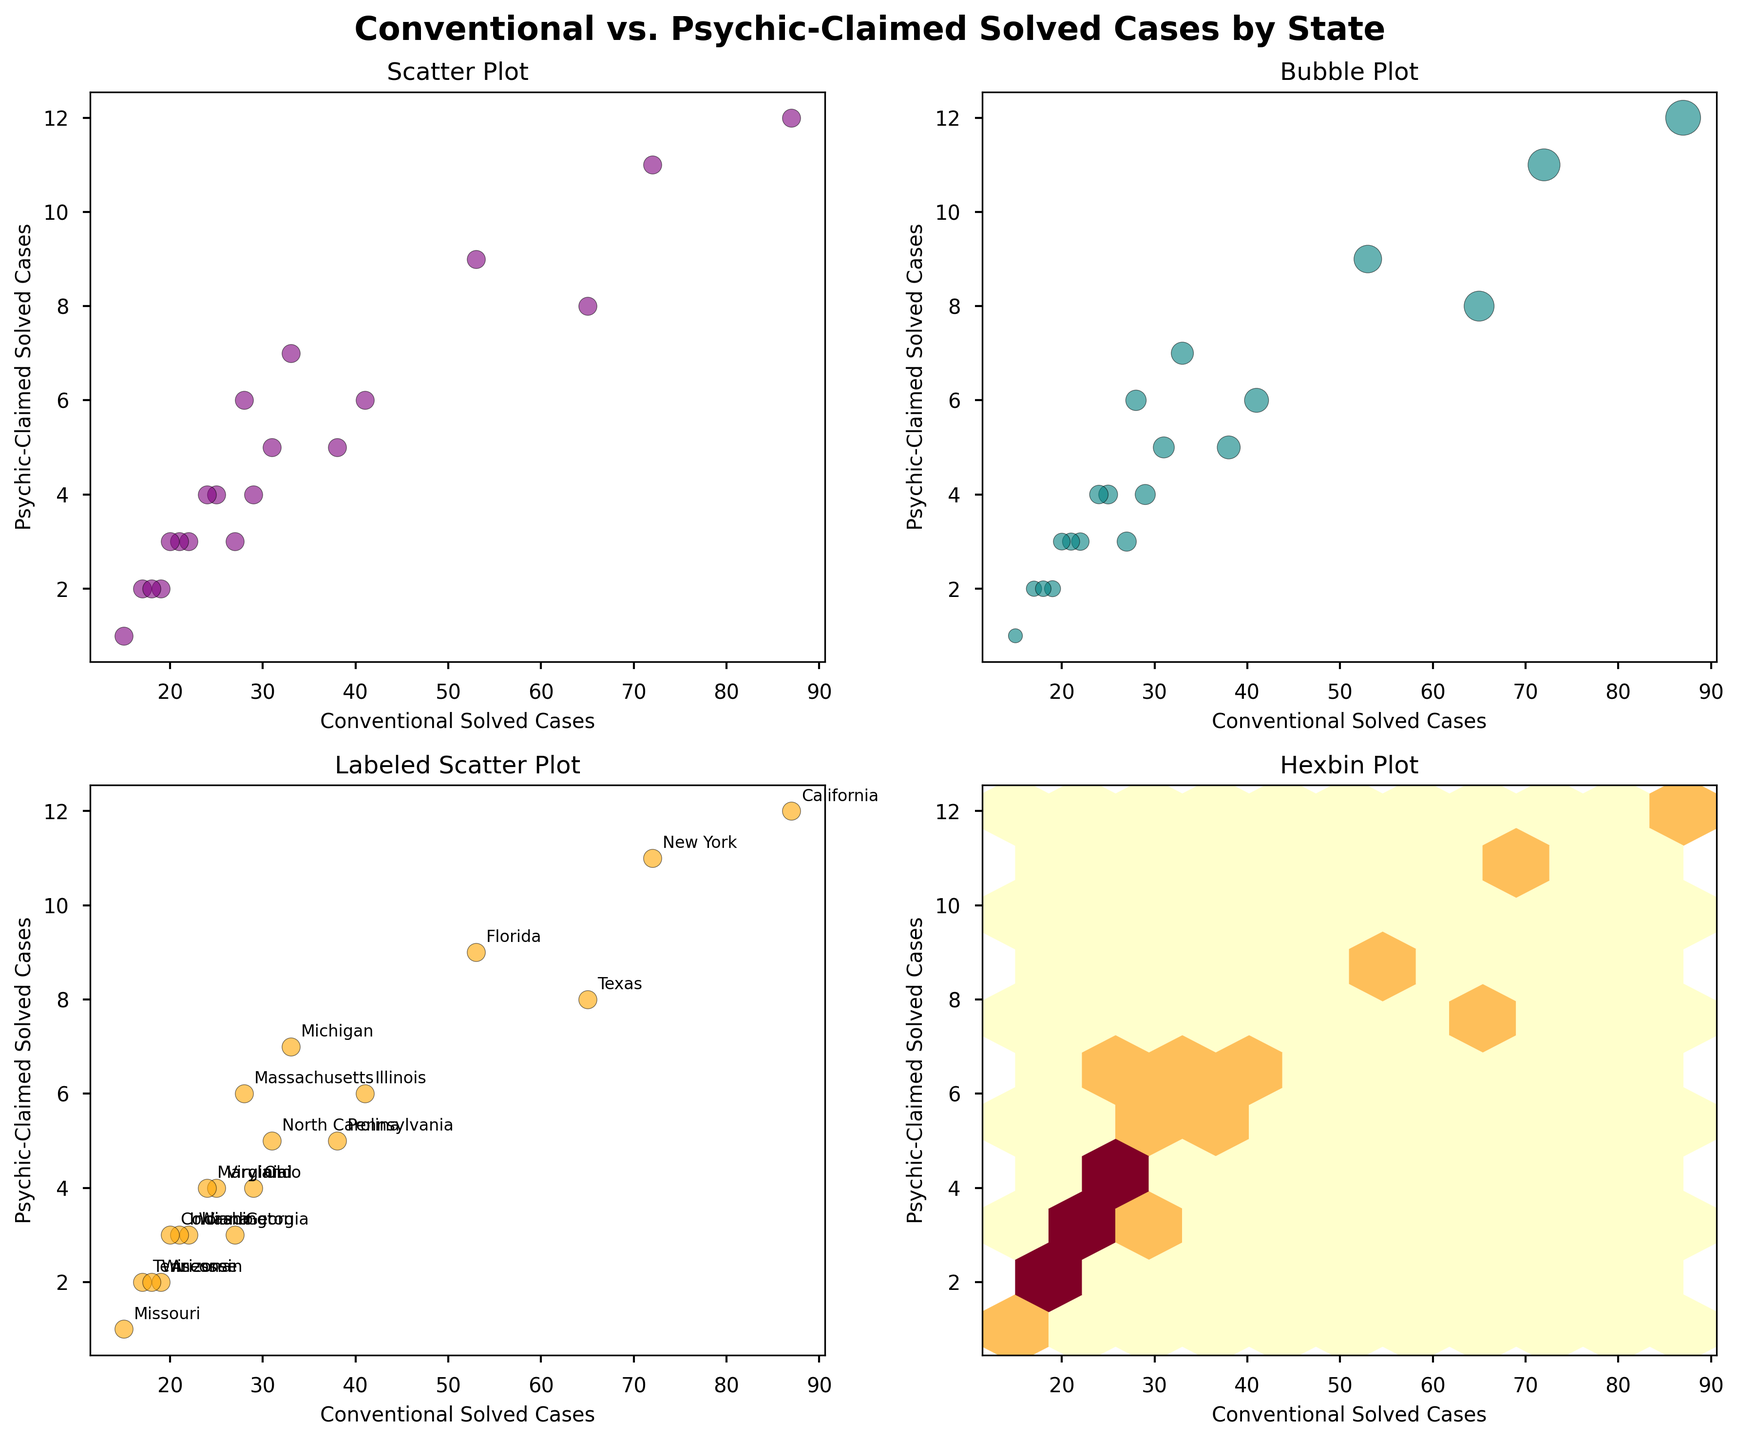what is the title of the figure? The title of the figure can be found at the top center of the subplot. It reads "Conventional vs. Psychic-Claimed Solved Cases by State."
Answer: Conventional vs. Psychic-Claimed Solved Cases by State What color is used for the scatter points in the first plot? The scatter points in the first plot are represented in purple, enhancing their visibility against the light background.
Answer: Purple How many states have exactly 3 psychic-claimed solved cases according to the labeled scatter plot? In the labeled scatter plot, the states that have exactly 3 psychic-claimed solved cases are Georgia, Washington, and Indiana. By counting these states, we find there are three.
Answer: 3 Which state has the highest number of conventional solved cases, and how many are there based on the labeled scatter plot? In the labeled scatter plot, California has the highest number of conventional solved cases. By matching the state label with the conventional solved cases, we see that California has 87 cases.
Answer: California, 87 What does the hexbin plot at the bottom right represent concerning conventional and psychic-claimed solved cases? The hexbin plot aggregates the data points into hexagonal bins, showing the density of cases. The darker the bin, the higher the concentration of both conventional and psychic-claimed solved cases within that range.
Answer: Density of cases What's the total number of conventional and psychic-solved cases for New York as seen in the labeled scatter plot? In the labeled scatter plot, New York's data points are matched for both conventional and psychic-claimed solved cases. New York has 72 conventional and 11 psychic-solved cases, totalling 83 solved cases.
Answer: 83 Which state has the smallest size bubble in the bubble plot and what does it indicate? The state with the smallest size bubble in the bubble plot is Missouri. The size of the bubble indicates the sum of conventional and psychic-claimed solved cases, which for Missouri is 16 (15 conventional + 1 psychic).
Answer: Missouri, 16 How do the conventional solved cases compare to psychic-claimed solved cases across all states in the scatter plot? In the scatter plot, conventional solved cases significantly outnumber psychic-claimed solved cases across all states. Each data point shows a higher value on the conventional axis than on the psychic axis.
Answer: Conventional > Psychic-Claimed In which range do most of the hexbin cells fall for conventional solved cases, and what does it signify? Most of the hexbin cells fall in the range of 20 to 40 conventional solved cases, signifying that a majority of states have their conventional solved cases within this range, as indicated by the yellow clusters.
Answer: 20 to 40 Which plot allows us to see the names of the states for each data point, and why is this important? The labeled scatter plot allows us to see the names of the states for each data point. This labeling is important for identifying specific states and making precise comparisons and analyses.
Answer: Labeled Scatter Plot 